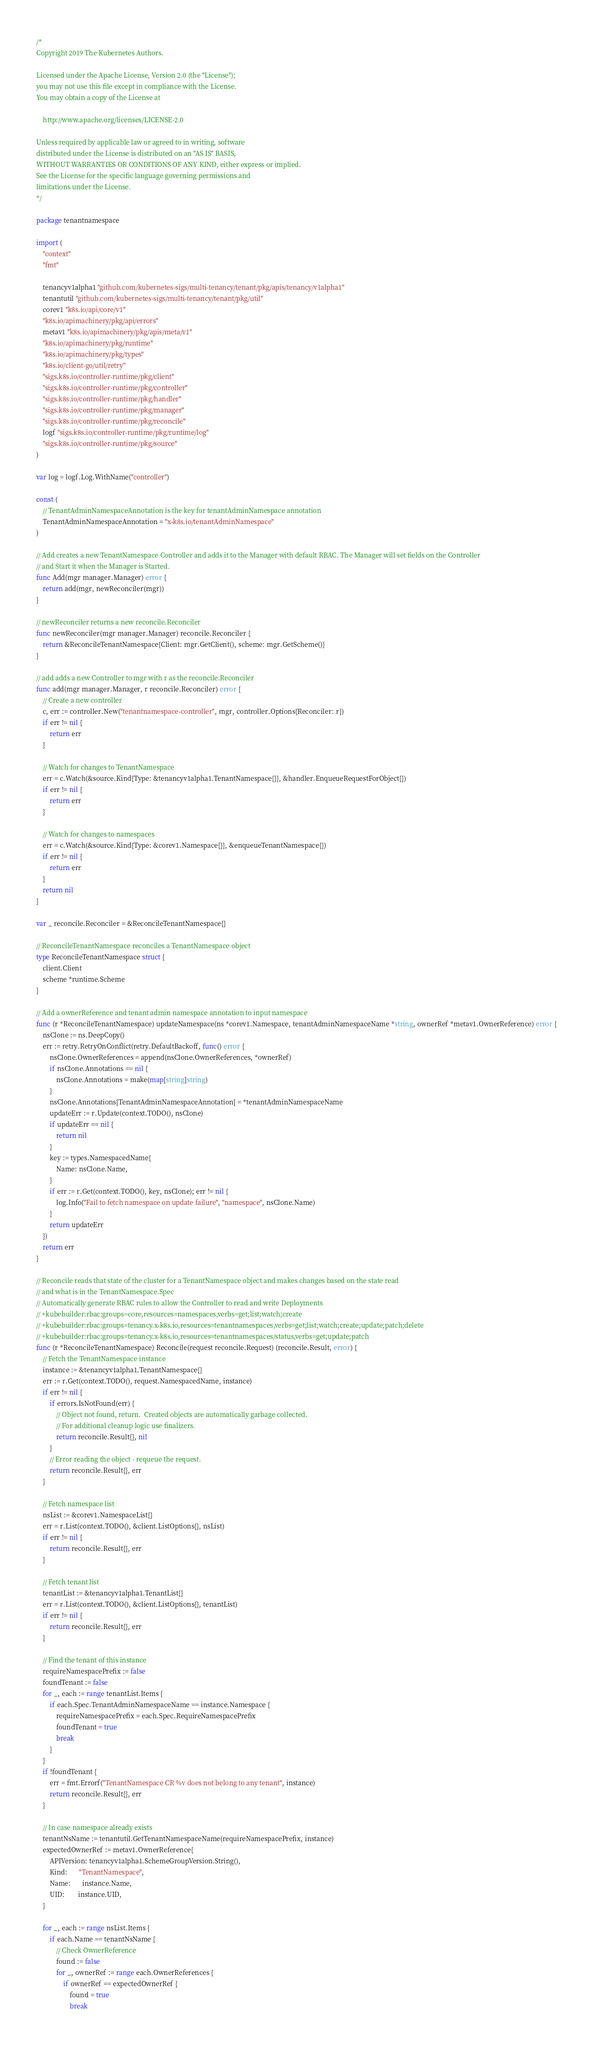Convert code to text. <code><loc_0><loc_0><loc_500><loc_500><_Go_>/*
Copyright 2019 The Kubernetes Authors.

Licensed under the Apache License, Version 2.0 (the "License");
you may not use this file except in compliance with the License.
You may obtain a copy of the License at

    http://www.apache.org/licenses/LICENSE-2.0

Unless required by applicable law or agreed to in writing, software
distributed under the License is distributed on an "AS IS" BASIS,
WITHOUT WARRANTIES OR CONDITIONS OF ANY KIND, either express or implied.
See the License for the specific language governing permissions and
limitations under the License.
*/

package tenantnamespace

import (
	"context"
	"fmt"

	tenancyv1alpha1 "github.com/kubernetes-sigs/multi-tenancy/tenant/pkg/apis/tenancy/v1alpha1"
	tenantutil "github.com/kubernetes-sigs/multi-tenancy/tenant/pkg/util"
	corev1 "k8s.io/api/core/v1"
	"k8s.io/apimachinery/pkg/api/errors"
	metav1 "k8s.io/apimachinery/pkg/apis/meta/v1"
	"k8s.io/apimachinery/pkg/runtime"
	"k8s.io/apimachinery/pkg/types"
	"k8s.io/client-go/util/retry"
	"sigs.k8s.io/controller-runtime/pkg/client"
	"sigs.k8s.io/controller-runtime/pkg/controller"
	"sigs.k8s.io/controller-runtime/pkg/handler"
	"sigs.k8s.io/controller-runtime/pkg/manager"
	"sigs.k8s.io/controller-runtime/pkg/reconcile"
	logf "sigs.k8s.io/controller-runtime/pkg/runtime/log"
	"sigs.k8s.io/controller-runtime/pkg/source"
)

var log = logf.Log.WithName("controller")

const (
	// TenantAdminNamespaceAnnotation is the key for tenantAdminNamespace annotation
	TenantAdminNamespaceAnnotation = "x-k8s.io/tenantAdminNamespace"
)

// Add creates a new TenantNamespace Controller and adds it to the Manager with default RBAC. The Manager will set fields on the Controller
// and Start it when the Manager is Started.
func Add(mgr manager.Manager) error {
	return add(mgr, newReconciler(mgr))
}

// newReconciler returns a new reconcile.Reconciler
func newReconciler(mgr manager.Manager) reconcile.Reconciler {
	return &ReconcileTenantNamespace{Client: mgr.GetClient(), scheme: mgr.GetScheme()}
}

// add adds a new Controller to mgr with r as the reconcile.Reconciler
func add(mgr manager.Manager, r reconcile.Reconciler) error {
	// Create a new controller
	c, err := controller.New("tenantnamespace-controller", mgr, controller.Options{Reconciler: r})
	if err != nil {
		return err
	}

	// Watch for changes to TenantNamespace
	err = c.Watch(&source.Kind{Type: &tenancyv1alpha1.TenantNamespace{}}, &handler.EnqueueRequestForObject{})
	if err != nil {
		return err
	}

	// Watch for changes to namespaces
	err = c.Watch(&source.Kind{Type: &corev1.Namespace{}}, &enqueueTenantNamespace{})
	if err != nil {
		return err
	}
	return nil
}

var _ reconcile.Reconciler = &ReconcileTenantNamespace{}

// ReconcileTenantNamespace reconciles a TenantNamespace object
type ReconcileTenantNamespace struct {
	client.Client
	scheme *runtime.Scheme
}

// Add a ownerReference and tenant admin namespace annotation to input namespace
func (r *ReconcileTenantNamespace) updateNamespace(ns *corev1.Namespace, tenantAdminNamespaceName *string, ownerRef *metav1.OwnerReference) error {
	nsClone := ns.DeepCopy()
	err := retry.RetryOnConflict(retry.DefaultBackoff, func() error {
		nsClone.OwnerReferences = append(nsClone.OwnerReferences, *ownerRef)
		if nsClone.Annotations == nil {
			nsClone.Annotations = make(map[string]string)
		}
		nsClone.Annotations[TenantAdminNamespaceAnnotation] = *tenantAdminNamespaceName
		updateErr := r.Update(context.TODO(), nsClone)
		if updateErr == nil {
			return nil
		}
		key := types.NamespacedName{
			Name: nsClone.Name,
		}
		if err := r.Get(context.TODO(), key, nsClone); err != nil {
			log.Info("Fail to fetch namespace on update failure", "namespace", nsClone.Name)
		}
		return updateErr
	})
	return err
}

// Reconcile reads that state of the cluster for a TenantNamespace object and makes changes based on the state read
// and what is in the TenantNamespace.Spec
// Automatically generate RBAC rules to allow the Controller to read and write Deployments
// +kubebuilder:rbac:groups=core,resources=namespaces,verbs=get;list;watch;create
// +kubebuilder:rbac:groups=tenancy.x-k8s.io,resources=tenantnamespaces,verbs=get;list;watch;create;update;patch;delete
// +kubebuilder:rbac:groups=tenancy.x-k8s.io,resources=tenantnamespaces/status,verbs=get;update;patch
func (r *ReconcileTenantNamespace) Reconcile(request reconcile.Request) (reconcile.Result, error) {
	// Fetch the TenantNamespace instance
	instance := &tenancyv1alpha1.TenantNamespace{}
	err := r.Get(context.TODO(), request.NamespacedName, instance)
	if err != nil {
		if errors.IsNotFound(err) {
			// Object not found, return.  Created objects are automatically garbage collected.
			// For additional cleanup logic use finalizers.
			return reconcile.Result{}, nil
		}
		// Error reading the object - requeue the request.
		return reconcile.Result{}, err
	}

	// Fetch namespace list
	nsList := &corev1.NamespaceList{}
	err = r.List(context.TODO(), &client.ListOptions{}, nsList)
	if err != nil {
		return reconcile.Result{}, err
	}

	// Fetch tenant list
	tenantList := &tenancyv1alpha1.TenantList{}
	err = r.List(context.TODO(), &client.ListOptions{}, tenantList)
	if err != nil {
		return reconcile.Result{}, err
	}

	// Find the tenant of this instance
	requireNamespacePrefix := false
	foundTenant := false
	for _, each := range tenantList.Items {
		if each.Spec.TenantAdminNamespaceName == instance.Namespace {
			requireNamespacePrefix = each.Spec.RequireNamespacePrefix
			foundTenant = true
			break
		}
	}
	if !foundTenant {
		err = fmt.Errorf("TenantNamespace CR %v does not belong to any tenant", instance)
		return reconcile.Result{}, err
	}

	// In case namespace already exists
	tenantNsName := tenantutil.GetTenantNamespaceName(requireNamespacePrefix, instance)
	expectedOwnerRef := metav1.OwnerReference{
		APIVersion: tenancyv1alpha1.SchemeGroupVersion.String(),
		Kind:       "TenantNamespace",
		Name:       instance.Name,
		UID:        instance.UID,
	}

	for _, each := range nsList.Items {
		if each.Name == tenantNsName {
			// Check OwnerReference
			found := false
			for _, ownerRef := range each.OwnerReferences {
				if ownerRef == expectedOwnerRef {
					found = true
					break</code> 